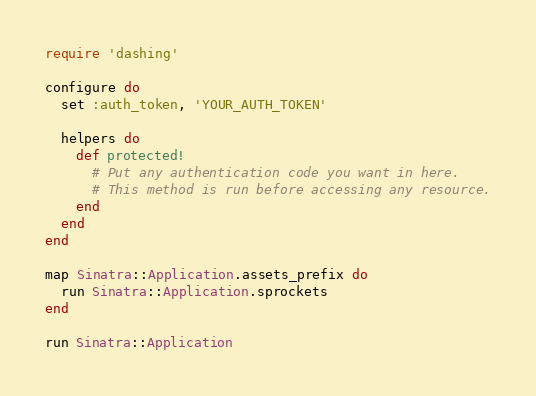<code> <loc_0><loc_0><loc_500><loc_500><_Ruby_>require 'dashing'

configure do
  set :auth_token, 'YOUR_AUTH_TOKEN'

  helpers do
    def protected!
      # Put any authentication code you want in here.
      # This method is run before accessing any resource.
    end
  end
end

map Sinatra::Application.assets_prefix do
  run Sinatra::Application.sprockets
end

run Sinatra::Application
</code> 